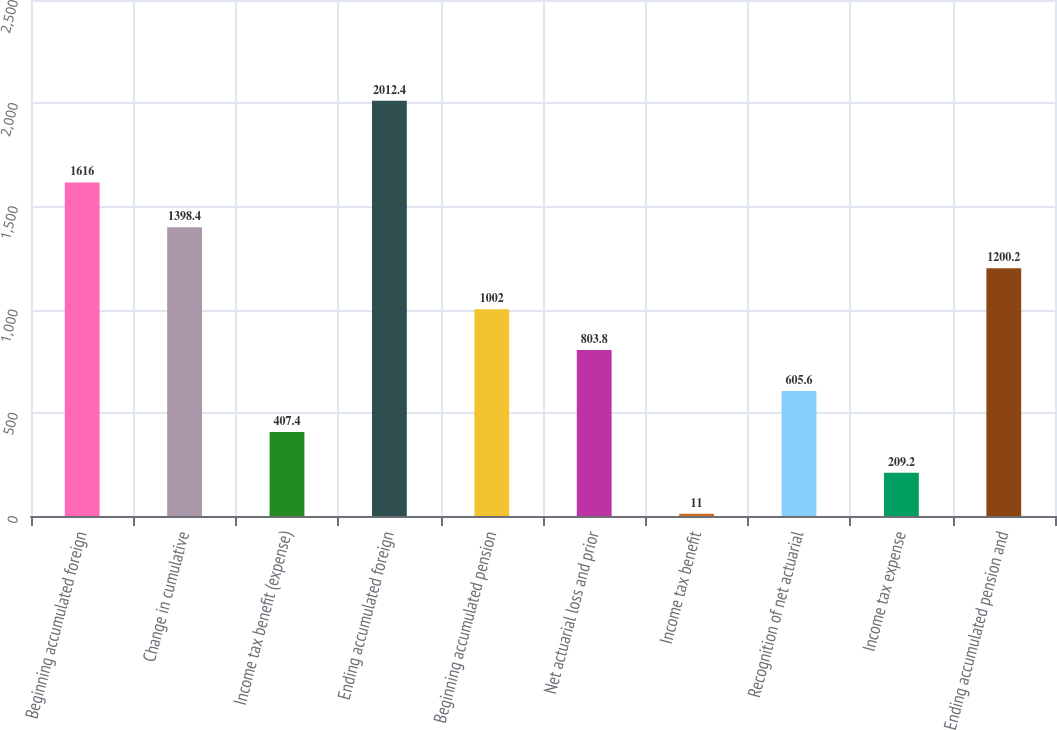Convert chart to OTSL. <chart><loc_0><loc_0><loc_500><loc_500><bar_chart><fcel>Beginning accumulated foreign<fcel>Change in cumulative<fcel>Income tax benefit (expense)<fcel>Ending accumulated foreign<fcel>Beginning accumulated pension<fcel>Net actuarial loss and prior<fcel>Income tax benefit<fcel>Recognition of net actuarial<fcel>Income tax expense<fcel>Ending accumulated pension and<nl><fcel>1616<fcel>1398.4<fcel>407.4<fcel>2012.4<fcel>1002<fcel>803.8<fcel>11<fcel>605.6<fcel>209.2<fcel>1200.2<nl></chart> 